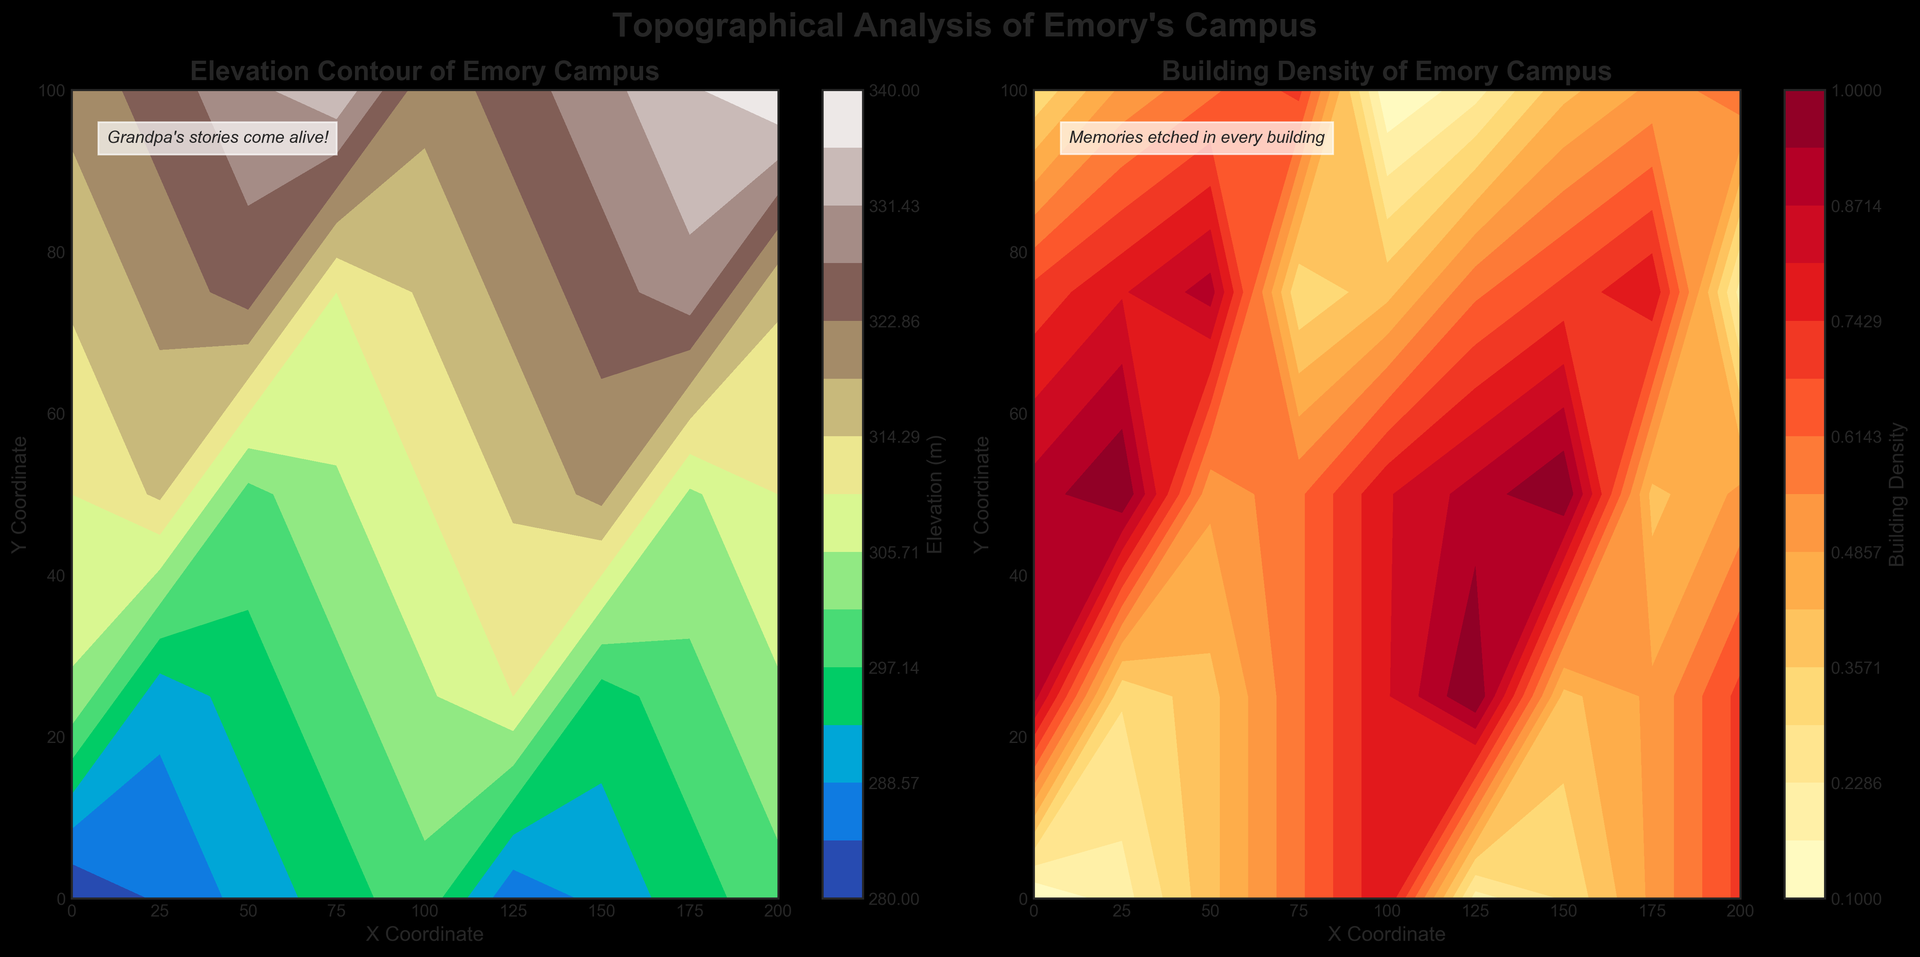What is the elevation at the highest point on the map? Look at the elevation contour plot and find the contour level with the highest value. The highest contour level in the plot indicates the highest elevation.
Answer: 340 meters Which area has a higher building density, (50, 50) or (75, 75)? Compare the building density values at these coordinates in the building density contour plot. (50, 50) has a building density of 0.6, and (75, 75) has a density of 0.9, so (75, 75) is higher.
Answer: (75, 75) Is the building density greater at (0, 0) or (200, 100)? Find the building density values for both coordinates in the building density contour plot. (0, 0) has a density of 0.1, and (200, 100) has a density of 0.6.
Answer: (200, 100) What is the average elevation of the points (0, 0), (100, 100), and (200, 0)? Look up the elevation values for these points: (0, 0) is 280, (100, 100) is 320, and (200, 0) is 320. Calculate the average: (280 + 320 + 320) / 3.
Answer: 306.67 meters Which point has a steeper elevation increase from (50, 0) to (75, 0) or from (175, 0) to (200, 0)? Calculate the elevation change for each range. From (50, 0) to (75, 0), elevation increases from 290 to 295 (change of 5). From (175, 0) to (200, 0), elevation increases from 315 to 320 (change of 5). Both increases are equal.
Answer: Equal Among the points (0, 0), (0, 100), and (200, 0), which has the lowest building density? Compare the building density values at these coordinates. (0, 0) has a density of 0.1, (0, 100) has 0.8, and (200, 0) has 0.1. Both (0, 0) and (200, 0) have the lowest density.
Answer: (0, 0) and (200, 0) If you walk along the path from (0, 25) to (0, 100), how much does the elevation increase? Subtract the elevation at (0, 25) which is 285 meters from the elevation at (0, 100) which is 300 meters. 300 - 285 = 15.
Answer: 15 meters Which coordinate has the darkest color in the elevation contour plot? The darkest color corresponds to the highest elevation. Look for the highest elevation value in the contour plot, which is 340 meters at (200, 100).
Answer: (200, 100) What coordinate has the highest building density in the plot? Find the point in the building density contour plot with the highest density. Multiple points have the highest density of 1.0, such as (50, 100), (75, 100), and (100, 100).
Answer: (50, 100), (75, 100), or (100, 100) Is the building density greater along the x-axis or the y-axis at x=100? Observe the building density contour plot at x=100. The density increases from 0.5 at y=0 to 1.0 at y=100. Along the y-axis, the density varies, but generally increases in this case.
Answer: y-axis 